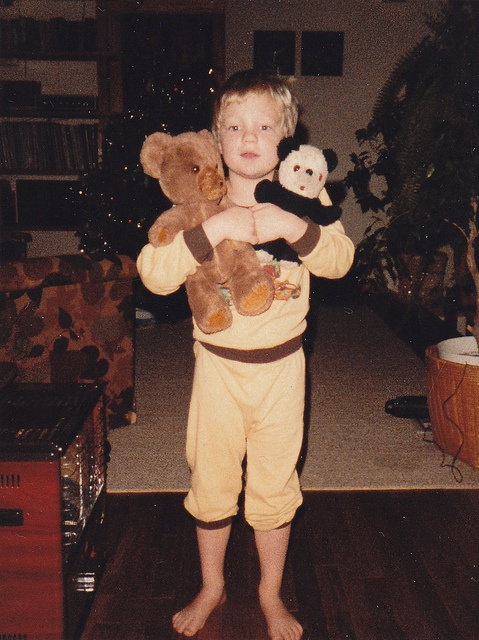Describe the objects in this image and their specific colors. I can see people in black, tan, and salmon tones, potted plant in black, maroon, and brown tones, couch in black, maroon, and brown tones, teddy bear in black, salmon, tan, and brown tones, and teddy bear in black and tan tones in this image. 